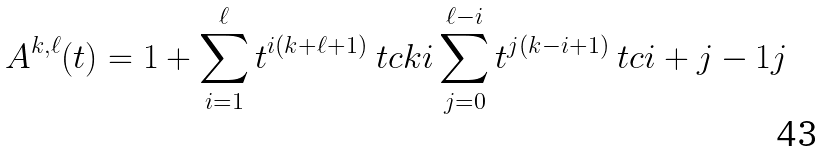<formula> <loc_0><loc_0><loc_500><loc_500>A ^ { k , \ell } ( t ) = 1 + \sum _ { i = 1 } ^ { \ell } t ^ { i ( k + \ell + 1 ) } \ t c { k } { i } \sum _ { j = 0 } ^ { \ell - i } t ^ { j ( k - i + 1 ) } \ t c { i + j - 1 } { j }</formula> 